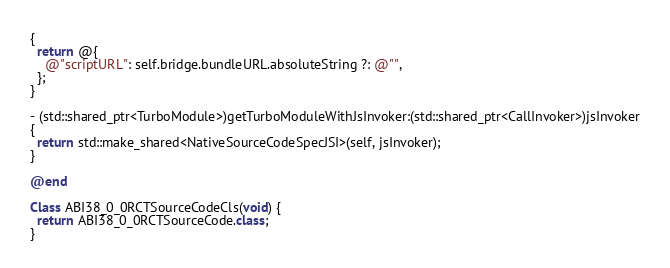<code> <loc_0><loc_0><loc_500><loc_500><_ObjectiveC_>{
  return @{
    @"scriptURL": self.bridge.bundleURL.absoluteString ?: @"",
  };
}

- (std::shared_ptr<TurboModule>)getTurboModuleWithJsInvoker:(std::shared_ptr<CallInvoker>)jsInvoker
{
  return std::make_shared<NativeSourceCodeSpecJSI>(self, jsInvoker);
}

@end

Class ABI38_0_0RCTSourceCodeCls(void) {
  return ABI38_0_0RCTSourceCode.class;
}
</code> 